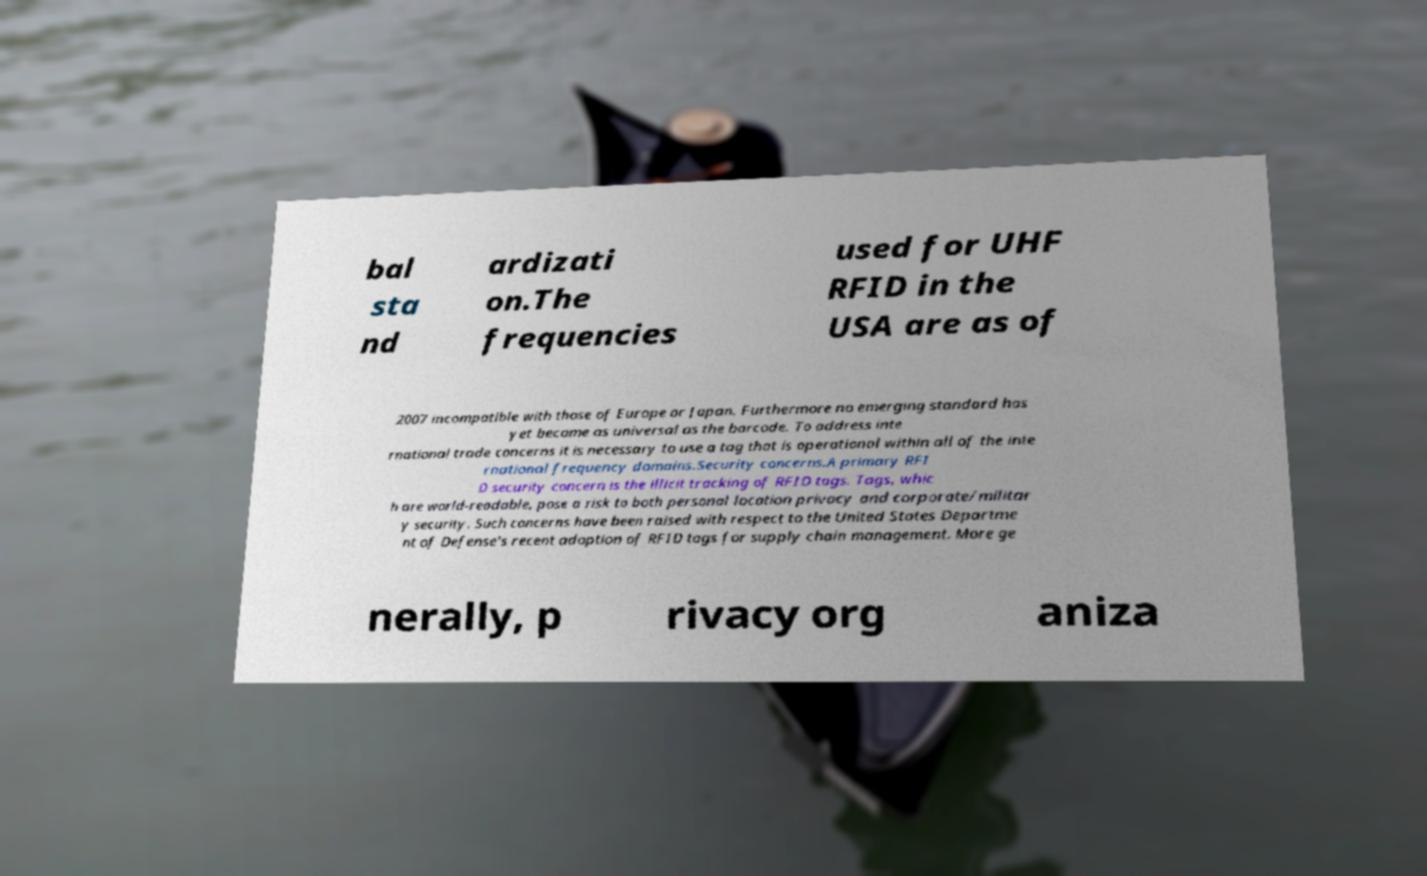Could you extract and type out the text from this image? bal sta nd ardizati on.The frequencies used for UHF RFID in the USA are as of 2007 incompatible with those of Europe or Japan. Furthermore no emerging standard has yet become as universal as the barcode. To address inte rnational trade concerns it is necessary to use a tag that is operational within all of the inte rnational frequency domains.Security concerns.A primary RFI D security concern is the illicit tracking of RFID tags. Tags, whic h are world-readable, pose a risk to both personal location privacy and corporate/militar y security. Such concerns have been raised with respect to the United States Departme nt of Defense's recent adoption of RFID tags for supply chain management. More ge nerally, p rivacy org aniza 